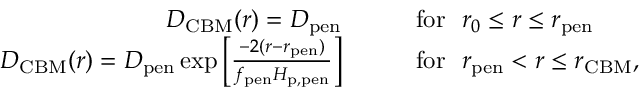<formula> <loc_0><loc_0><loc_500><loc_500>\begin{array} { r l } { D _ { C B M } ( r ) = D _ { p e n } \quad } & { f o r \ \ r _ { 0 } \leq r \leq r _ { p e n } } \\ { D _ { C B M } ( r ) = D _ { p e n } \exp \left [ \frac { - 2 ( r - r _ { p e n } ) } { f _ { p e n } H _ { p , p e n } } \right ] \quad } & { f o r \ \ r _ { p e n } < r \leq r _ { C B M } , } \end{array}</formula> 